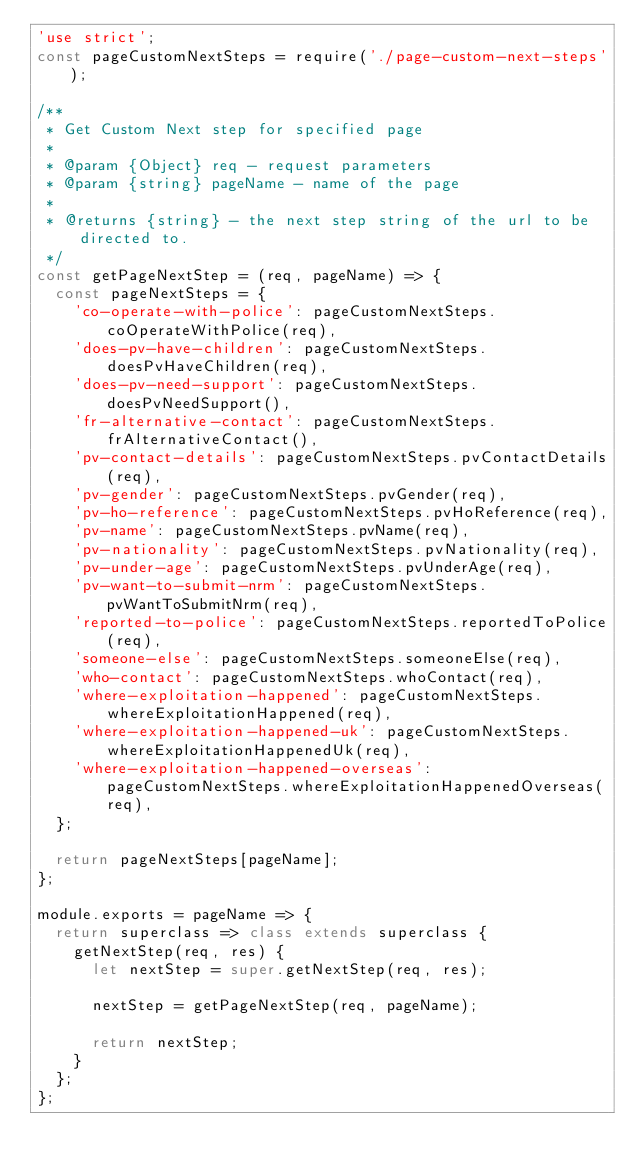Convert code to text. <code><loc_0><loc_0><loc_500><loc_500><_JavaScript_>'use strict';
const pageCustomNextSteps = require('./page-custom-next-steps');

/**
 * Get Custom Next step for specified page
 *
 * @param {Object} req - request parameters
 * @param {string} pageName - name of the page
 *
 * @returns {string} - the next step string of the url to be directed to.
 */
const getPageNextStep = (req, pageName) => {
  const pageNextSteps = {
    'co-operate-with-police': pageCustomNextSteps.coOperateWithPolice(req),
    'does-pv-have-children': pageCustomNextSteps.doesPvHaveChildren(req),
    'does-pv-need-support': pageCustomNextSteps.doesPvNeedSupport(),
    'fr-alternative-contact': pageCustomNextSteps.frAlternativeContact(),
    'pv-contact-details': pageCustomNextSteps.pvContactDetails(req),
    'pv-gender': pageCustomNextSteps.pvGender(req),
    'pv-ho-reference': pageCustomNextSteps.pvHoReference(req),
    'pv-name': pageCustomNextSteps.pvName(req),
    'pv-nationality': pageCustomNextSteps.pvNationality(req),
    'pv-under-age': pageCustomNextSteps.pvUnderAge(req),
    'pv-want-to-submit-nrm': pageCustomNextSteps.pvWantToSubmitNrm(req),
    'reported-to-police': pageCustomNextSteps.reportedToPolice(req),
    'someone-else': pageCustomNextSteps.someoneElse(req),
    'who-contact': pageCustomNextSteps.whoContact(req),
    'where-exploitation-happened': pageCustomNextSteps.whereExploitationHappened(req),
    'where-exploitation-happened-uk': pageCustomNextSteps.whereExploitationHappenedUk(req),
    'where-exploitation-happened-overseas': pageCustomNextSteps.whereExploitationHappenedOverseas(req),
  };

  return pageNextSteps[pageName];
};

module.exports = pageName => {
  return superclass => class extends superclass {
    getNextStep(req, res) {
      let nextStep = super.getNextStep(req, res);

      nextStep = getPageNextStep(req, pageName);

      return nextStep;
    }
  };
};
</code> 